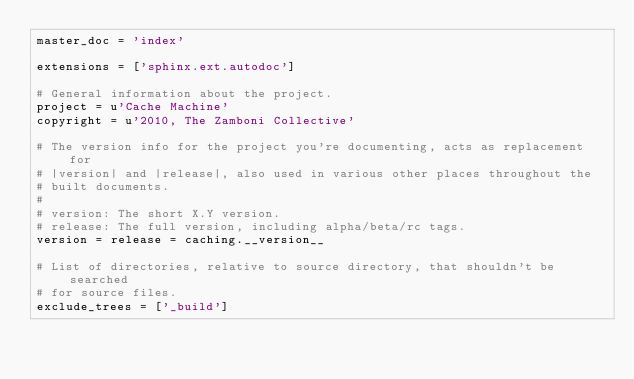<code> <loc_0><loc_0><loc_500><loc_500><_Python_>master_doc = 'index'

extensions = ['sphinx.ext.autodoc']

# General information about the project.
project = u'Cache Machine'
copyright = u'2010, The Zamboni Collective'

# The version info for the project you're documenting, acts as replacement for
# |version| and |release|, also used in various other places throughout the
# built documents.
#
# version: The short X.Y version.
# release: The full version, including alpha/beta/rc tags.
version = release = caching.__version__

# List of directories, relative to source directory, that shouldn't be searched
# for source files.
exclude_trees = ['_build']
</code> 